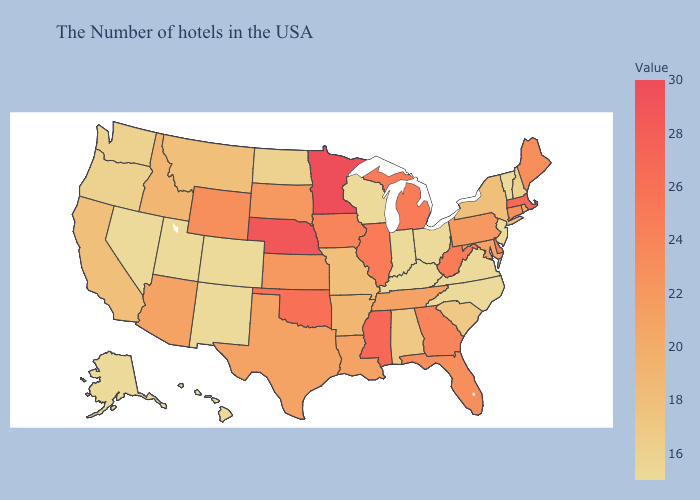Among the states that border North Dakota , does Montana have the highest value?
Write a very short answer. No. Does the map have missing data?
Write a very short answer. No. Among the states that border Arkansas , which have the highest value?
Give a very brief answer. Mississippi. Which states hav the highest value in the Northeast?
Concise answer only. Massachusetts. Which states have the lowest value in the Northeast?
Be succinct. Vermont, New Jersey. Does Iowa have the highest value in the USA?
Give a very brief answer. No. 